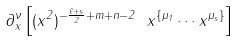<formula> <loc_0><loc_0><loc_500><loc_500>\partial _ { x } ^ { \nu } \left [ ( x ^ { 2 } ) ^ { - \frac { \ell + s } { 2 } + m + n - 2 } \ x ^ { \{ \mu _ { 1 } } \cdots x ^ { \mu _ { s } \} } \right ]</formula> 